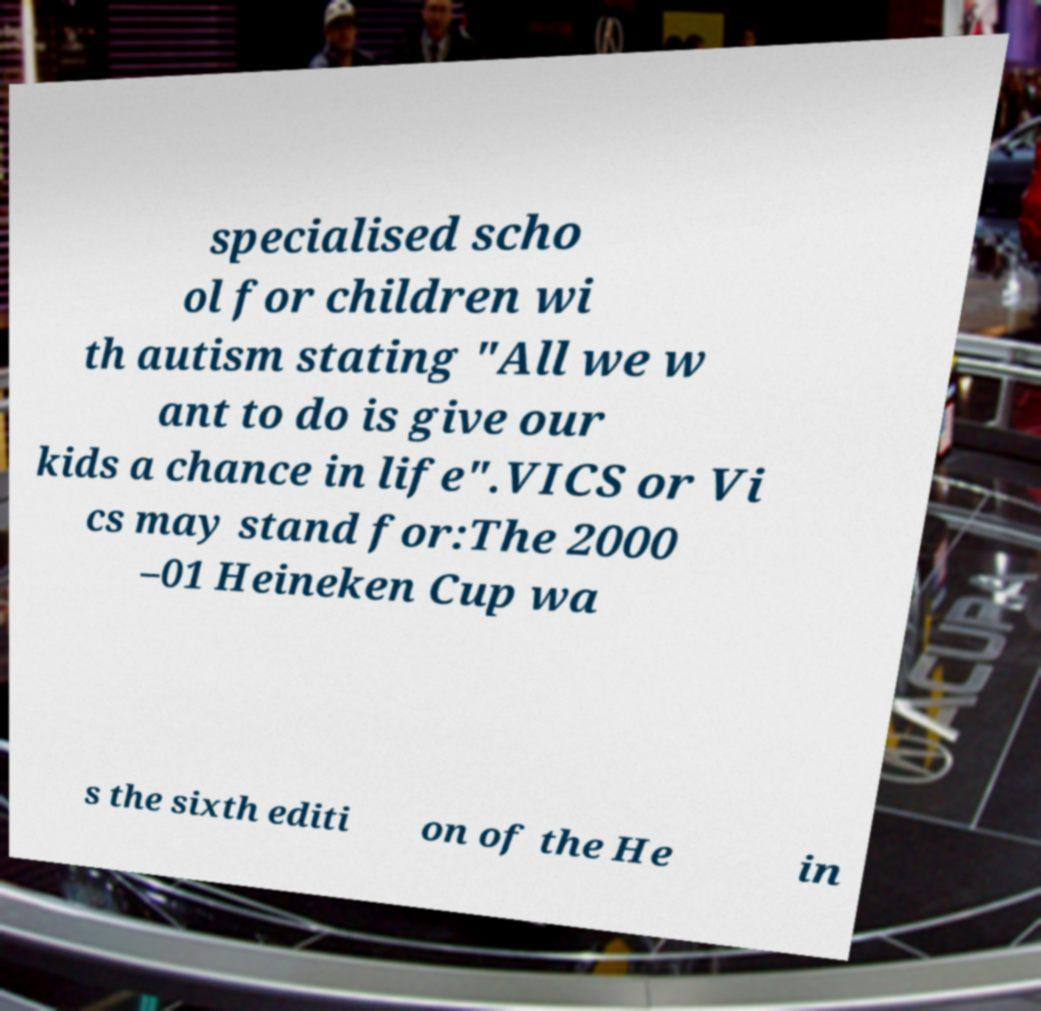Can you accurately transcribe the text from the provided image for me? specialised scho ol for children wi th autism stating "All we w ant to do is give our kids a chance in life".VICS or Vi cs may stand for:The 2000 –01 Heineken Cup wa s the sixth editi on of the He in 